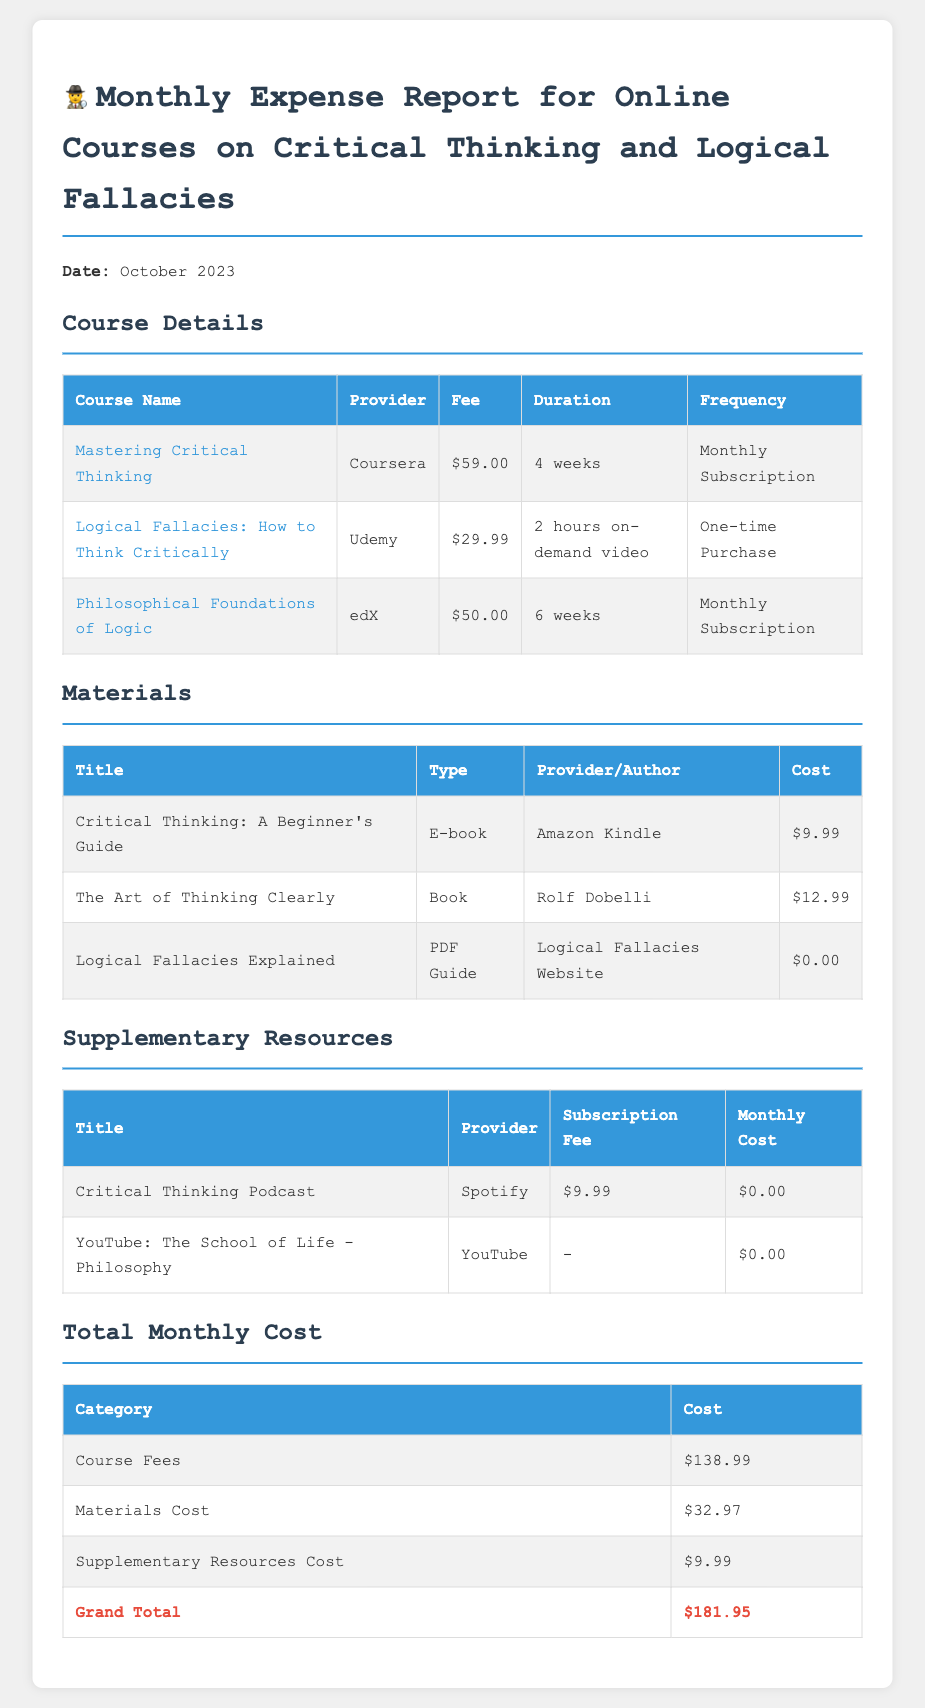What is the total monthly cost? The total monthly cost is the sum of all category costs listed in the document, which is $181.95.
Answer: $181.95 How much is the fee for "Mastering Critical Thinking"? The fee for "Mastering Critical Thinking" is specified in the Course Details table of the document.
Answer: $59.00 What type of resource is "Logical Fallacies Explained"? "Logical Fallacies Explained" is classified under the Materials section of the document, which specifies it as a PDF Guide.
Answer: PDF Guide Who is the provider for "The Art of Thinking Clearly"? The provider for "The Art of Thinking Clearly" is found under the Materials section in the document.
Answer: Rolf Dobelli What is the cost of supplementary resources? The total cost for supplementary resources is detailed in the Total Monthly Cost section of the document.
Answer: $9.99 How many weeks is the "Philosophical Foundations of Logic" course? The duration of the "Philosophical Foundations of Logic" course is mentioned in the Course Details table within the document.
Answer: 6 weeks What is the title of the e-book listed in the Materials section? The title of the e-book is found directly in the Materials table of the document.
Answer: Critical Thinking: A Beginner's Guide What is the course fee for "Logical Fallacies: How to Think Critically"? The course fee for "Logical Fallacies: How to Think Critically" is identified in the Course Details section.
Answer: $29.99 How much does the Critical Thinking Podcast cost? The cost for the Critical Thinking Podcast is provided in the Supplementary Resources section of the document.
Answer: $9.99 